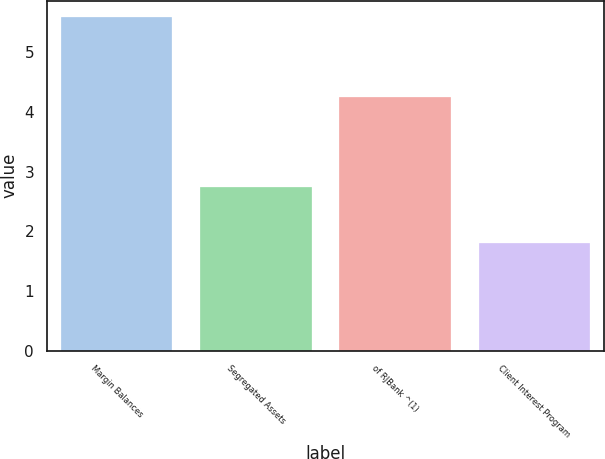Convert chart. <chart><loc_0><loc_0><loc_500><loc_500><bar_chart><fcel>Margin Balances<fcel>Segregated Assets<fcel>of RJBank ^(1)<fcel>Client Interest Program<nl><fcel>5.59<fcel>2.75<fcel>4.26<fcel>1.81<nl></chart> 